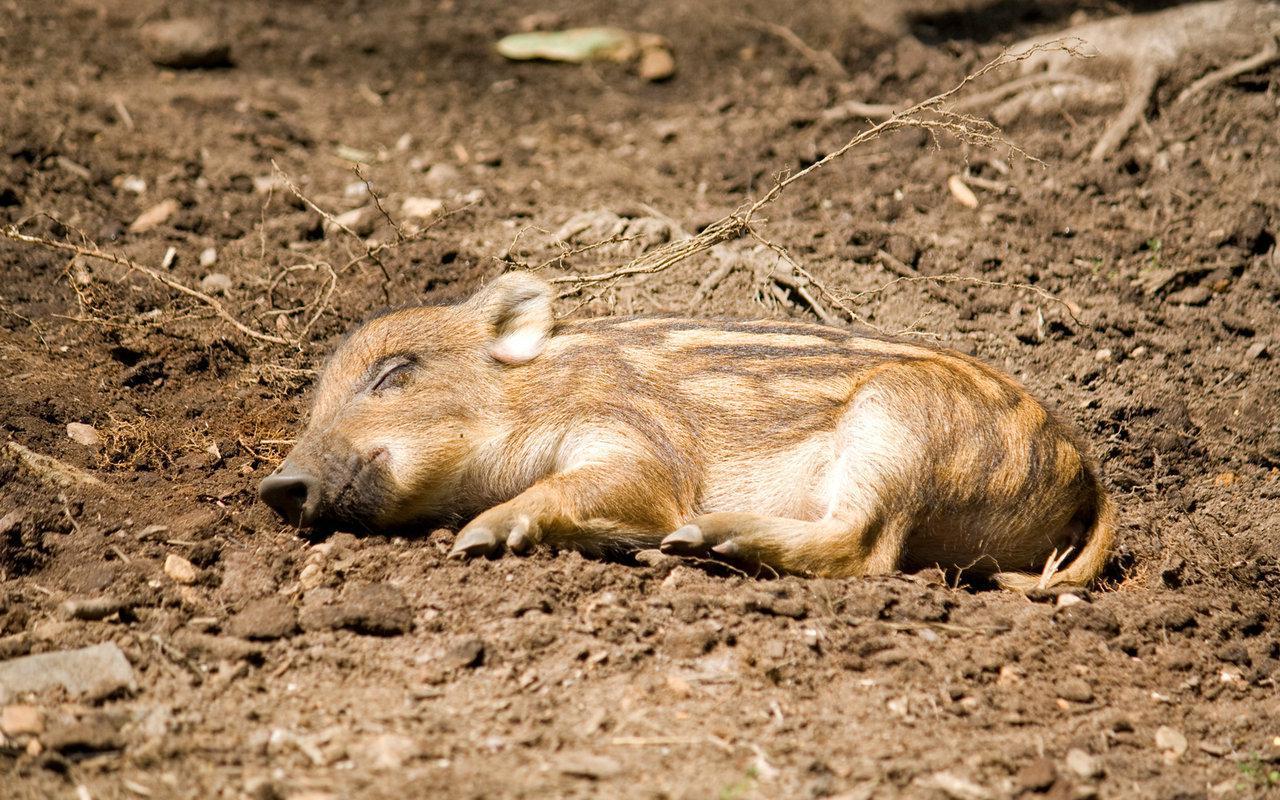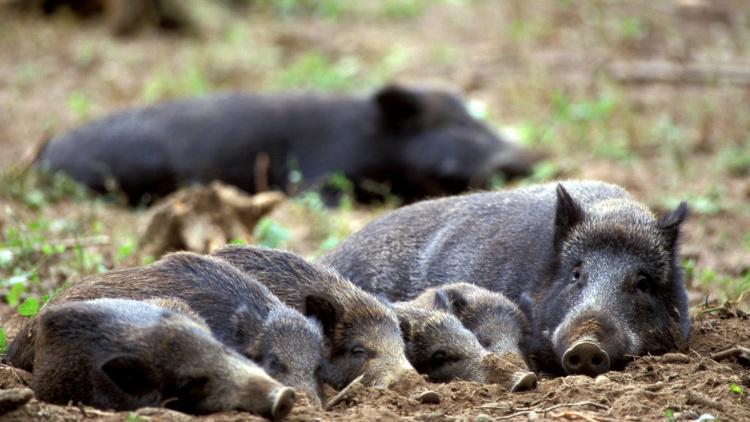The first image is the image on the left, the second image is the image on the right. Assess this claim about the two images: "There are two hogs in the pair of images.". Correct or not? Answer yes or no. No. The first image is the image on the left, the second image is the image on the right. Evaluate the accuracy of this statement regarding the images: "All pigs are in sleeping poses, and at least one pig is a baby with distinctive stripes.". Is it true? Answer yes or no. Yes. 